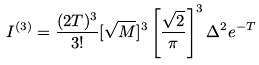<formula> <loc_0><loc_0><loc_500><loc_500>I ^ { ( 3 ) } = \frac { ( 2 T ) ^ { 3 } } { 3 ! } [ \sqrt { M } ] ^ { 3 } \left [ \frac { \sqrt { 2 } } { \pi } \right ] ^ { 3 } \Delta ^ { 2 } e ^ { - T }</formula> 